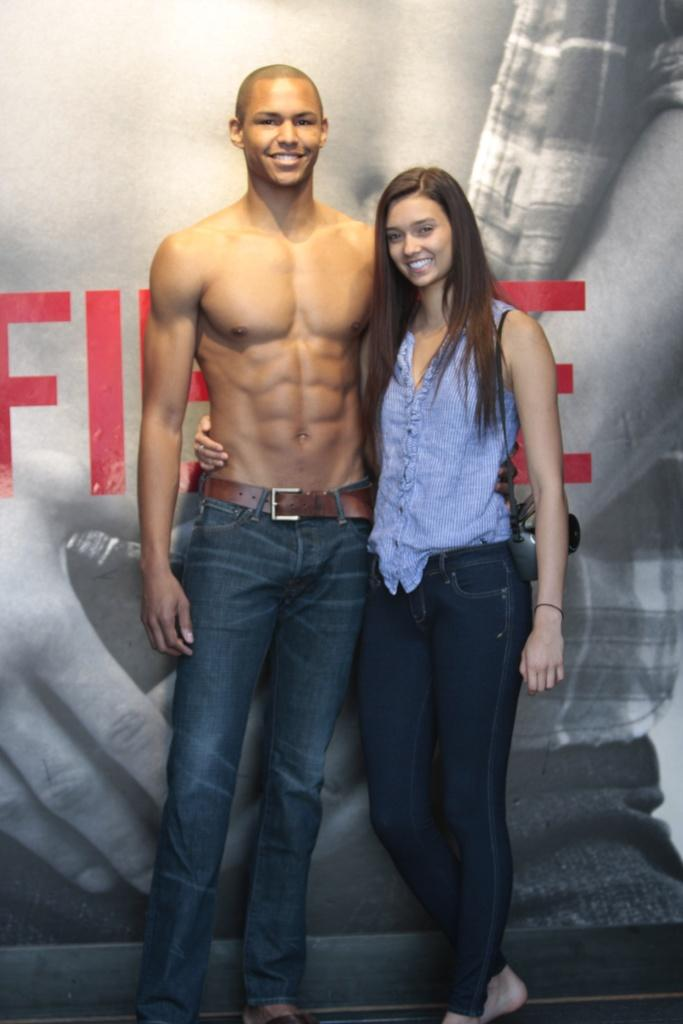How many people are in the image? There are two people in the image, a man and a woman. What are the man and woman doing in the image? Both the man and woman are standing and smiling. What can be seen in the background of the image? There is a poster in the background of the image. What type of history can be seen sparking between the man and woman in the image? There is no indication of any historical events or interactions between the man and woman in the image. Additionally, the term "spark" is not relevant to the image, as it does not depict any sparks or electrical activity. 